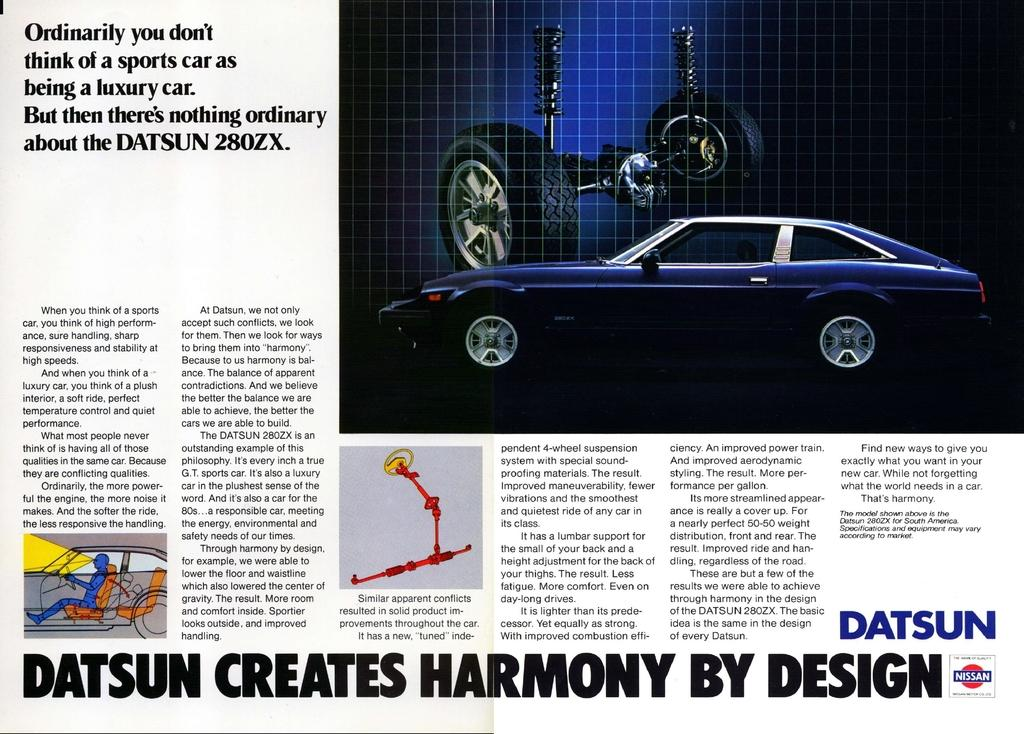What is the main subject of the picture? The main subject of the picture is an image of a car. Is there any text associated with the image of the car? Yes, there is text beside and below the image of the car. Are there any other images in the picture besides the car? Yes, there are other images in the picture. What type of earth can be seen in the image? There is no earth visible in the image; it features an image of a car with text and other images. What kind of vessel is used to transport the car in the image? There is no vessel present in the image, as it is a static picture of a car and other images. 